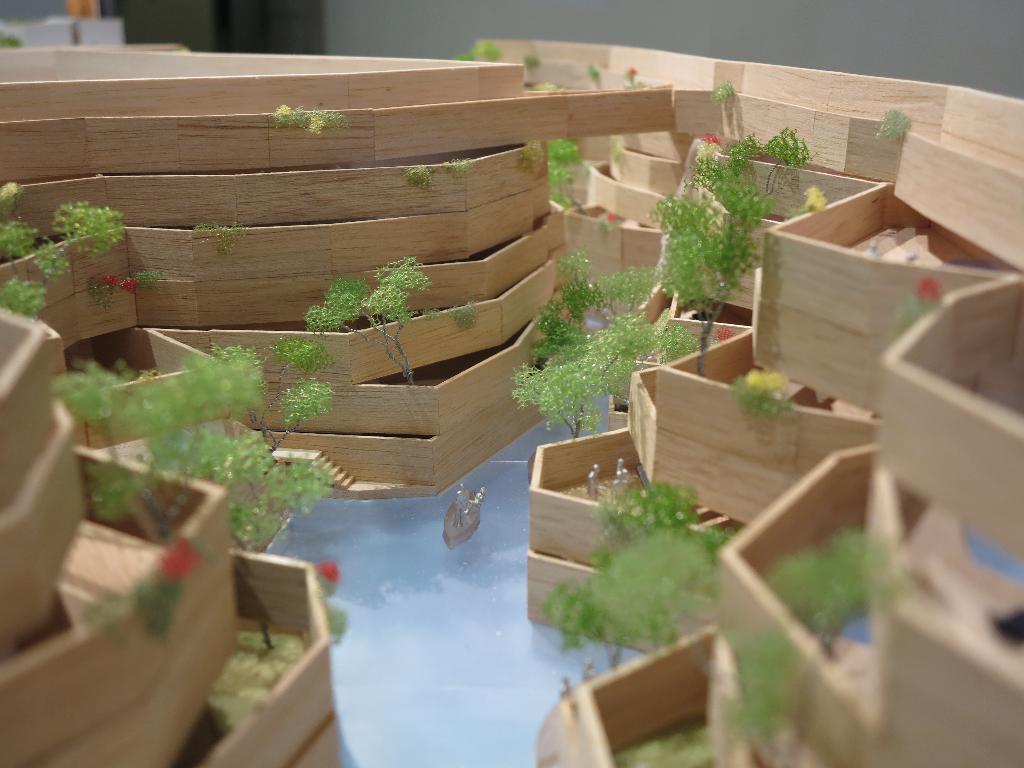Can you describe this image briefly? In the image I can see a project like thing which is made of wooden and also I can see some plants and some other things around. 